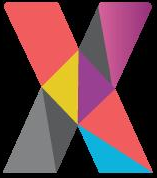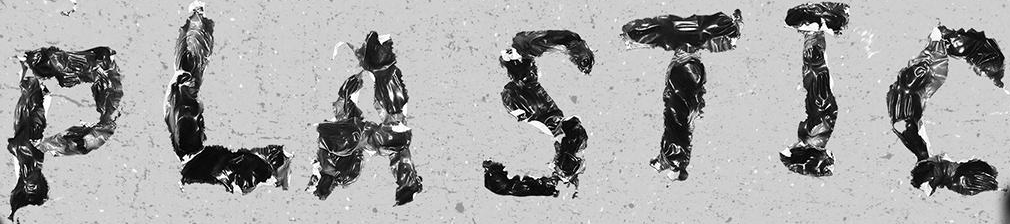What text appears in these images from left to right, separated by a semicolon? X; PLASTIC 